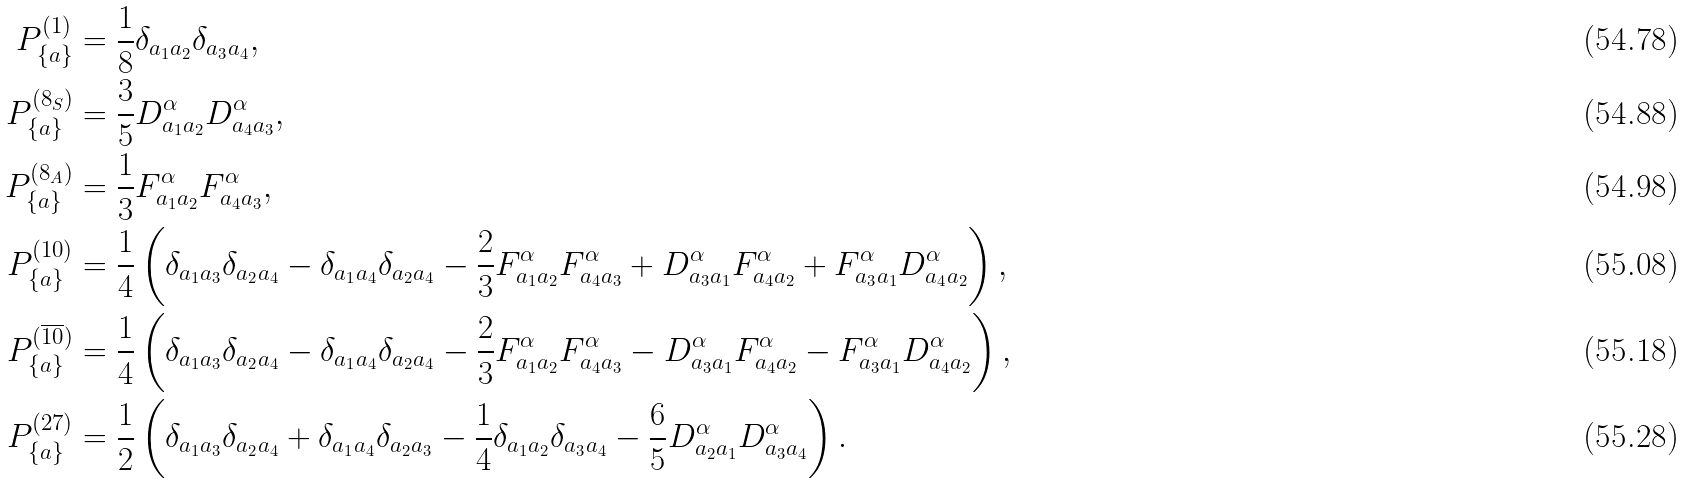Convert formula to latex. <formula><loc_0><loc_0><loc_500><loc_500>P ^ { ( 1 ) } _ { \{ a \} } & = \frac { 1 } { 8 } \delta _ { a _ { 1 } a _ { 2 } } \delta _ { a _ { 3 } a _ { 4 } } , \\ P ^ { ( 8 _ { S } ) } _ { \{ a \} } & = \frac { 3 } { 5 } D ^ { \alpha } _ { a _ { 1 } a _ { 2 } } D ^ { \alpha } _ { a _ { 4 } a _ { 3 } } , \\ P ^ { ( 8 _ { A } ) } _ { \{ a \} } & = \frac { 1 } { 3 } F ^ { \alpha } _ { a _ { 1 } a _ { 2 } } F ^ { \alpha } _ { a _ { 4 } a _ { 3 } } , \\ P ^ { ( 1 0 ) } _ { \{ a \} } & = \frac { 1 } { 4 } \left ( \delta _ { a _ { 1 } a _ { 3 } } \delta _ { a _ { 2 } a _ { 4 } } - \delta _ { a _ { 1 } a _ { 4 } } \delta _ { a _ { 2 } a _ { 4 } } - \frac { 2 } { 3 } F ^ { \alpha } _ { a _ { 1 } a _ { 2 } } F ^ { \alpha } _ { a _ { 4 } a _ { 3 } } + D ^ { \alpha } _ { a _ { 3 } a _ { 1 } } F ^ { \alpha } _ { a _ { 4 } a _ { 2 } } + F ^ { \alpha } _ { a _ { 3 } a _ { 1 } } D ^ { \alpha } _ { a _ { 4 } a _ { 2 } } \right ) , \\ P ^ { ( \overline { 1 0 } ) } _ { \{ a \} } & = \frac { 1 } { 4 } \left ( \delta _ { a _ { 1 } a _ { 3 } } \delta _ { a _ { 2 } a _ { 4 } } - \delta _ { a _ { 1 } a _ { 4 } } \delta _ { a _ { 2 } a _ { 4 } } - \frac { 2 } { 3 } F ^ { \alpha } _ { a _ { 1 } a _ { 2 } } F ^ { \alpha } _ { a _ { 4 } a _ { 3 } } - D ^ { \alpha } _ { a _ { 3 } a _ { 1 } } F ^ { \alpha } _ { a _ { 4 } a _ { 2 } } - F ^ { \alpha } _ { a _ { 3 } a _ { 1 } } D ^ { \alpha } _ { a _ { 4 } a _ { 2 } } \right ) , \\ P ^ { ( 2 7 ) } _ { \{ a \} } & = \frac { 1 } { 2 } \left ( \delta _ { a _ { 1 } a _ { 3 } } \delta _ { a _ { 2 } a _ { 4 } } + \delta _ { a _ { 1 } a _ { 4 } } \delta _ { a _ { 2 } a _ { 3 } } - \frac { 1 } { 4 } \delta _ { a _ { 1 } a _ { 2 } } \delta _ { a _ { 3 } a _ { 4 } } - \frac { 6 } { 5 } D ^ { \alpha } _ { a _ { 2 } a _ { 1 } } D ^ { \alpha } _ { a _ { 3 } a _ { 4 } } \right ) .</formula> 